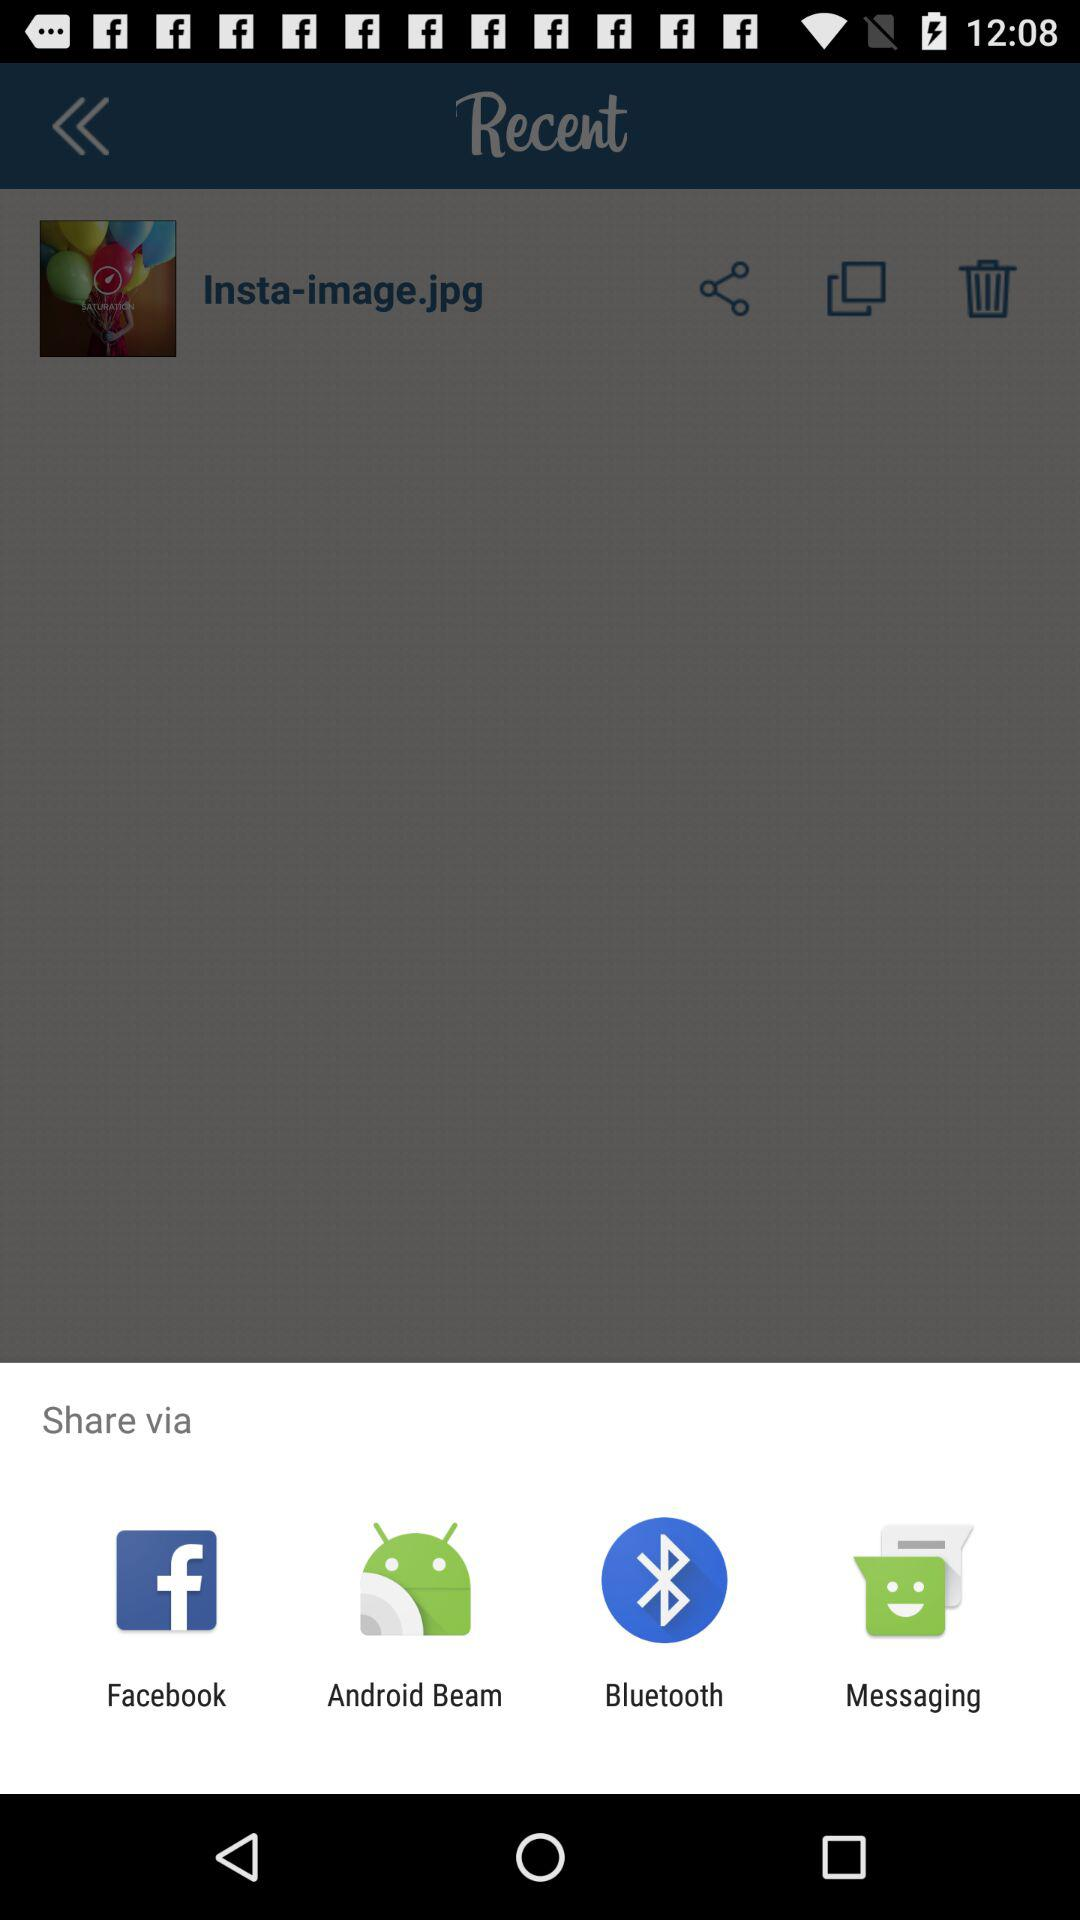How many images are deleted?
When the provided information is insufficient, respond with <no answer>. <no answer> 